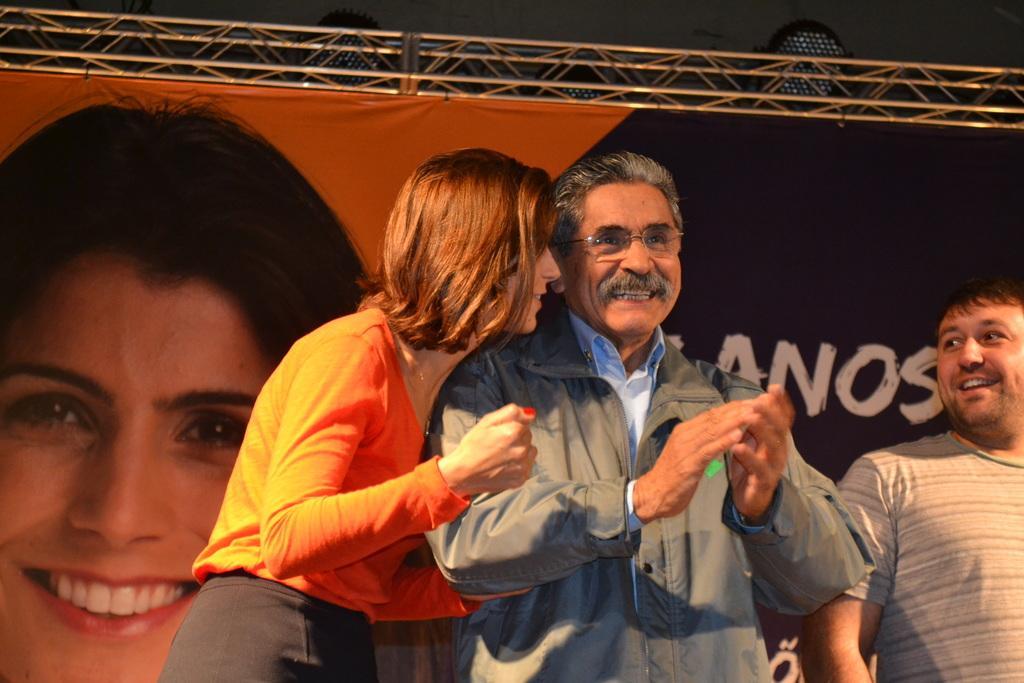In one or two sentences, can you explain what this image depicts? In this image I can see three persons standing. In front the person is wearing gray color blazer and blue shirt and the person at left is wearing an orange color shirt and gray short. Background I can see the banner and the banner is in orange and black color and I can see the person's face on the banner. 